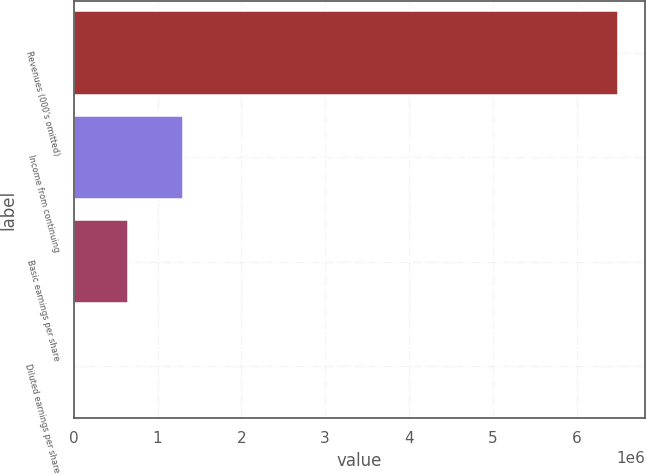Convert chart to OTSL. <chart><loc_0><loc_0><loc_500><loc_500><bar_chart><fcel>Revenues (000's omitted)<fcel>Income from continuing<fcel>Basic earnings per share<fcel>Diluted earnings per share<nl><fcel>6.4948e+06<fcel>1.29896e+06<fcel>649485<fcel>5.62<nl></chart> 